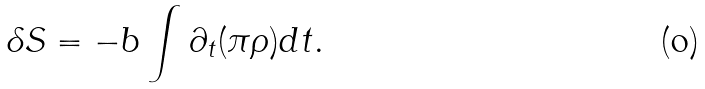Convert formula to latex. <formula><loc_0><loc_0><loc_500><loc_500>\delta S = - b \int \partial _ { t } ( \pi \rho ) d t .</formula> 